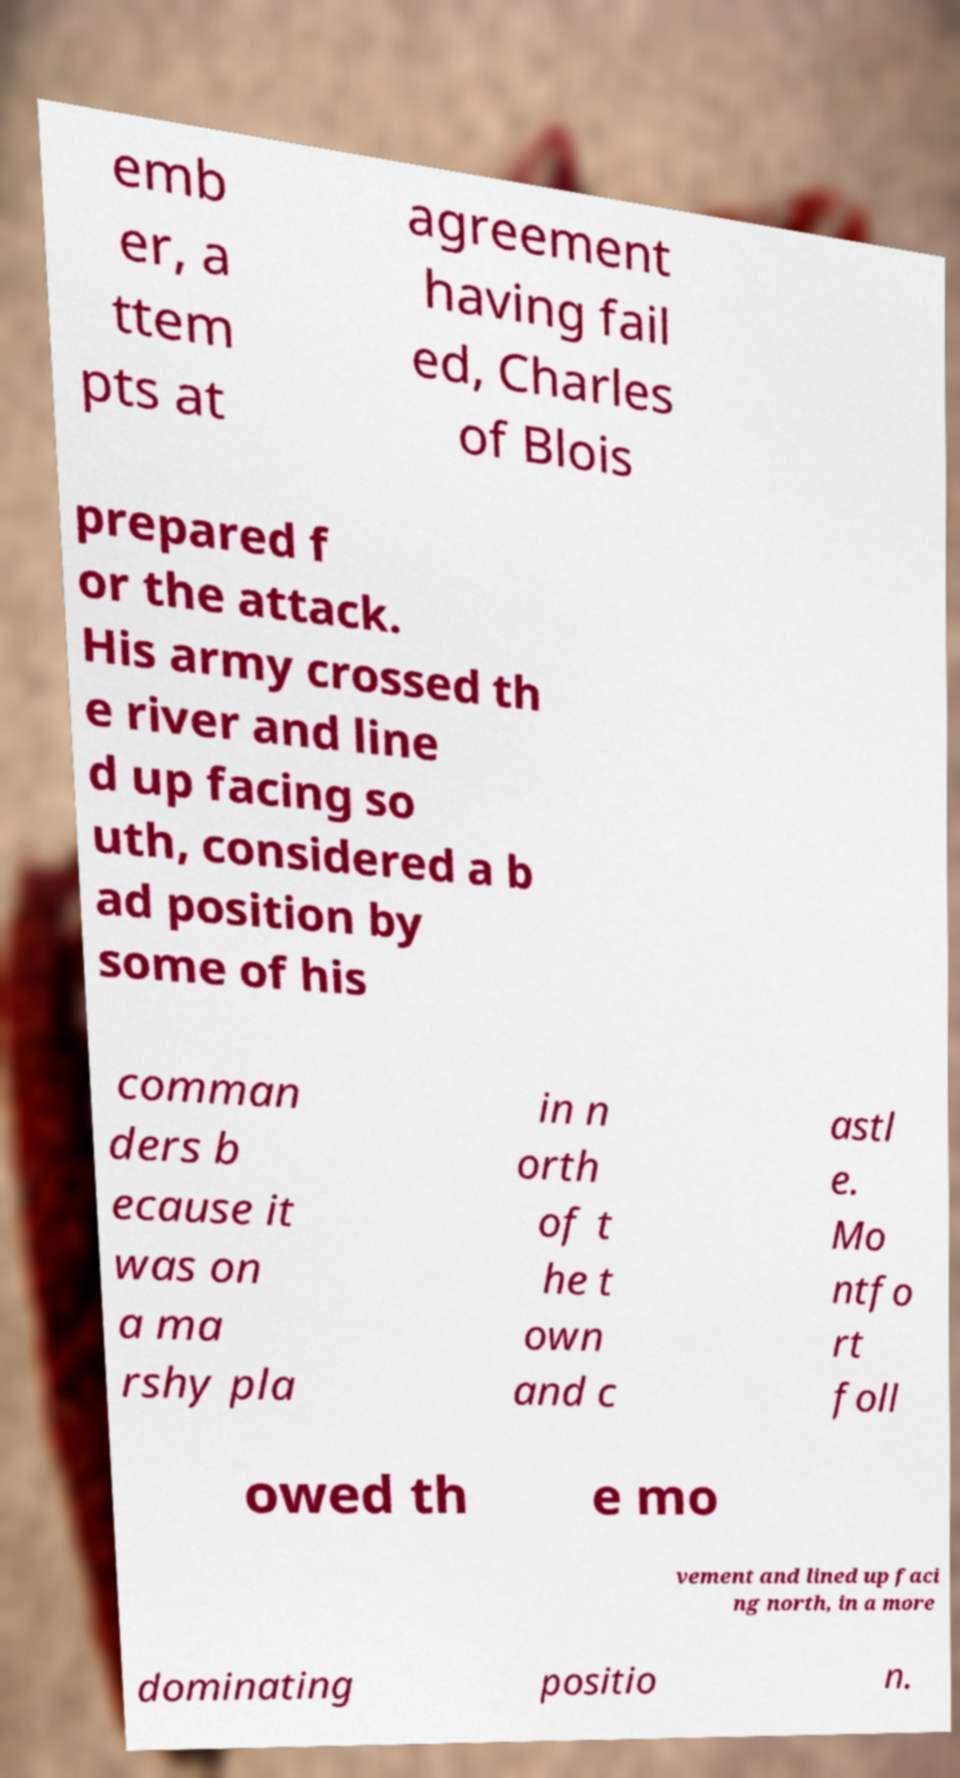Please read and relay the text visible in this image. What does it say? emb er, a ttem pts at agreement having fail ed, Charles of Blois prepared f or the attack. His army crossed th e river and line d up facing so uth, considered a b ad position by some of his comman ders b ecause it was on a ma rshy pla in n orth of t he t own and c astl e. Mo ntfo rt foll owed th e mo vement and lined up faci ng north, in a more dominating positio n. 